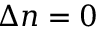Convert formula to latex. <formula><loc_0><loc_0><loc_500><loc_500>\Delta n = 0</formula> 